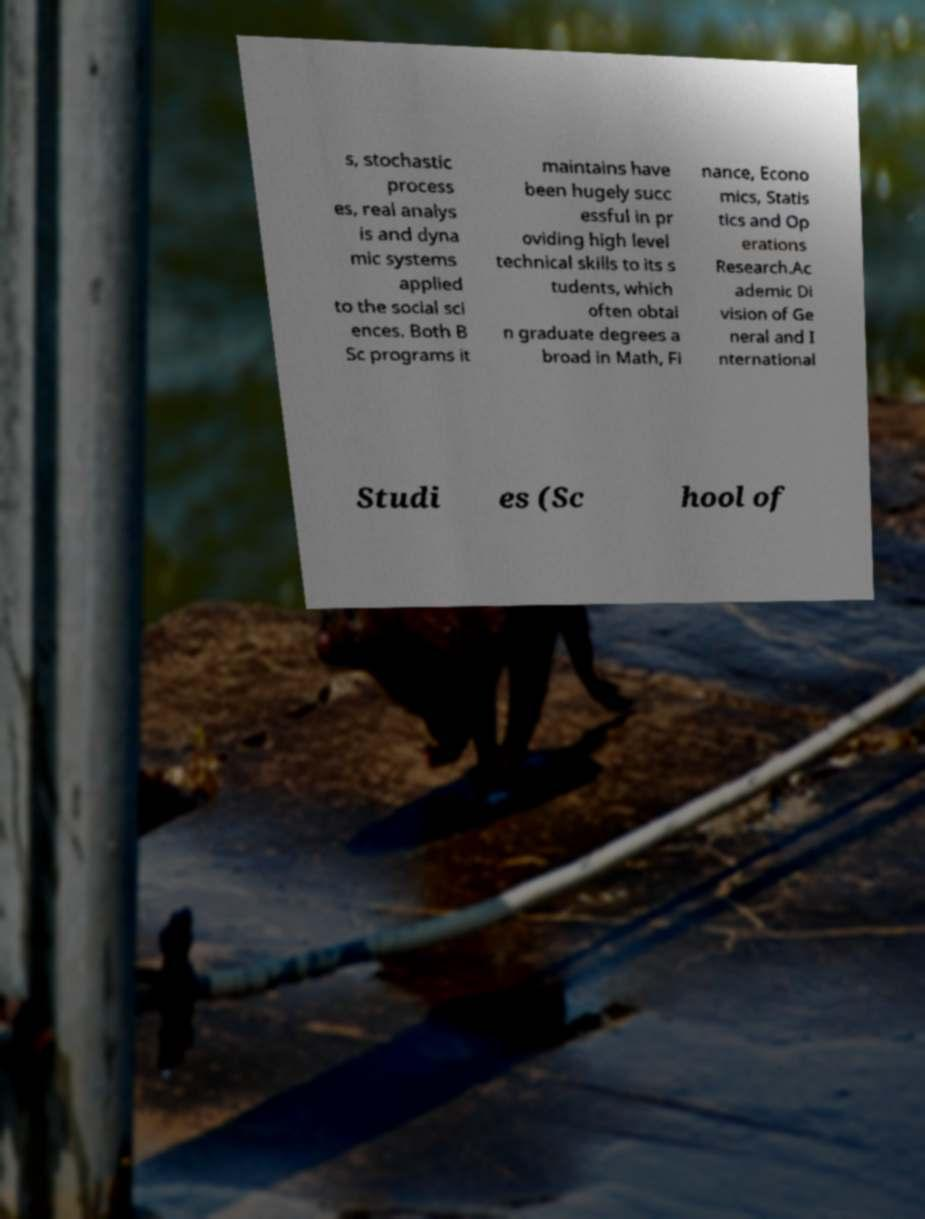There's text embedded in this image that I need extracted. Can you transcribe it verbatim? s, stochastic process es, real analys is and dyna mic systems applied to the social sci ences. Both B Sc programs it maintains have been hugely succ essful in pr oviding high level technical skills to its s tudents, which often obtai n graduate degrees a broad in Math, Fi nance, Econo mics, Statis tics and Op erations Research.Ac ademic Di vision of Ge neral and I nternational Studi es (Sc hool of 